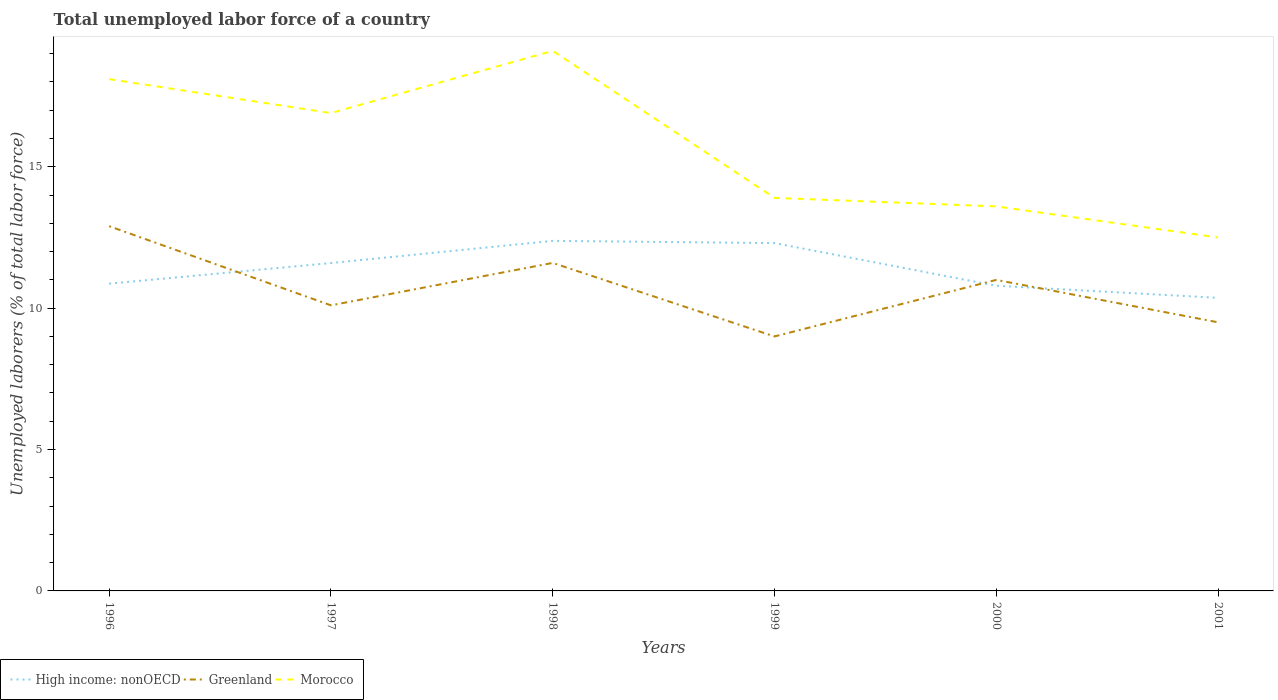Does the line corresponding to Greenland intersect with the line corresponding to High income: nonOECD?
Offer a very short reply. Yes. Across all years, what is the maximum total unemployed labor force in Morocco?
Your answer should be compact. 12.5. What is the total total unemployed labor force in Greenland in the graph?
Your answer should be compact. -0.9. What is the difference between the highest and the second highest total unemployed labor force in High income: nonOECD?
Ensure brevity in your answer.  2.01. Is the total unemployed labor force in Morocco strictly greater than the total unemployed labor force in Greenland over the years?
Ensure brevity in your answer.  No. Does the graph contain any zero values?
Ensure brevity in your answer.  No. Does the graph contain grids?
Keep it short and to the point. No. How many legend labels are there?
Provide a short and direct response. 3. How are the legend labels stacked?
Keep it short and to the point. Horizontal. What is the title of the graph?
Give a very brief answer. Total unemployed labor force of a country. What is the label or title of the Y-axis?
Provide a short and direct response. Unemployed laborers (% of total labor force). What is the Unemployed laborers (% of total labor force) in High income: nonOECD in 1996?
Keep it short and to the point. 10.87. What is the Unemployed laborers (% of total labor force) of Greenland in 1996?
Offer a very short reply. 12.9. What is the Unemployed laborers (% of total labor force) of Morocco in 1996?
Your answer should be compact. 18.1. What is the Unemployed laborers (% of total labor force) of High income: nonOECD in 1997?
Keep it short and to the point. 11.6. What is the Unemployed laborers (% of total labor force) in Greenland in 1997?
Keep it short and to the point. 10.1. What is the Unemployed laborers (% of total labor force) in Morocco in 1997?
Provide a succinct answer. 16.9. What is the Unemployed laborers (% of total labor force) of High income: nonOECD in 1998?
Ensure brevity in your answer.  12.38. What is the Unemployed laborers (% of total labor force) of Greenland in 1998?
Your answer should be very brief. 11.6. What is the Unemployed laborers (% of total labor force) in Morocco in 1998?
Your answer should be compact. 19.1. What is the Unemployed laborers (% of total labor force) of High income: nonOECD in 1999?
Keep it short and to the point. 12.3. What is the Unemployed laborers (% of total labor force) of Greenland in 1999?
Provide a short and direct response. 9. What is the Unemployed laborers (% of total labor force) of Morocco in 1999?
Provide a short and direct response. 13.9. What is the Unemployed laborers (% of total labor force) of High income: nonOECD in 2000?
Keep it short and to the point. 10.79. What is the Unemployed laborers (% of total labor force) in Greenland in 2000?
Your answer should be very brief. 11. What is the Unemployed laborers (% of total labor force) in Morocco in 2000?
Provide a succinct answer. 13.6. What is the Unemployed laborers (% of total labor force) of High income: nonOECD in 2001?
Offer a very short reply. 10.37. What is the Unemployed laborers (% of total labor force) of Greenland in 2001?
Make the answer very short. 9.5. What is the Unemployed laborers (% of total labor force) in Morocco in 2001?
Keep it short and to the point. 12.5. Across all years, what is the maximum Unemployed laborers (% of total labor force) of High income: nonOECD?
Give a very brief answer. 12.38. Across all years, what is the maximum Unemployed laborers (% of total labor force) of Greenland?
Make the answer very short. 12.9. Across all years, what is the maximum Unemployed laborers (% of total labor force) of Morocco?
Your response must be concise. 19.1. Across all years, what is the minimum Unemployed laborers (% of total labor force) of High income: nonOECD?
Provide a short and direct response. 10.37. Across all years, what is the minimum Unemployed laborers (% of total labor force) in Greenland?
Offer a terse response. 9. Across all years, what is the minimum Unemployed laborers (% of total labor force) of Morocco?
Your answer should be compact. 12.5. What is the total Unemployed laborers (% of total labor force) of High income: nonOECD in the graph?
Your response must be concise. 68.3. What is the total Unemployed laborers (% of total labor force) in Greenland in the graph?
Keep it short and to the point. 64.1. What is the total Unemployed laborers (% of total labor force) in Morocco in the graph?
Make the answer very short. 94.1. What is the difference between the Unemployed laborers (% of total labor force) in High income: nonOECD in 1996 and that in 1997?
Your response must be concise. -0.73. What is the difference between the Unemployed laborers (% of total labor force) in Greenland in 1996 and that in 1997?
Your response must be concise. 2.8. What is the difference between the Unemployed laborers (% of total labor force) in Morocco in 1996 and that in 1997?
Provide a succinct answer. 1.2. What is the difference between the Unemployed laborers (% of total labor force) of High income: nonOECD in 1996 and that in 1998?
Ensure brevity in your answer.  -1.51. What is the difference between the Unemployed laborers (% of total labor force) of Greenland in 1996 and that in 1998?
Your answer should be compact. 1.3. What is the difference between the Unemployed laborers (% of total labor force) of Morocco in 1996 and that in 1998?
Give a very brief answer. -1. What is the difference between the Unemployed laborers (% of total labor force) in High income: nonOECD in 1996 and that in 1999?
Provide a short and direct response. -1.44. What is the difference between the Unemployed laborers (% of total labor force) in Morocco in 1996 and that in 1999?
Your answer should be compact. 4.2. What is the difference between the Unemployed laborers (% of total labor force) in High income: nonOECD in 1996 and that in 2000?
Your response must be concise. 0.07. What is the difference between the Unemployed laborers (% of total labor force) of Greenland in 1996 and that in 2000?
Give a very brief answer. 1.9. What is the difference between the Unemployed laborers (% of total labor force) of Morocco in 1996 and that in 2000?
Ensure brevity in your answer.  4.5. What is the difference between the Unemployed laborers (% of total labor force) of High income: nonOECD in 1996 and that in 2001?
Your answer should be very brief. 0.5. What is the difference between the Unemployed laborers (% of total labor force) of Greenland in 1996 and that in 2001?
Make the answer very short. 3.4. What is the difference between the Unemployed laborers (% of total labor force) in High income: nonOECD in 1997 and that in 1998?
Keep it short and to the point. -0.78. What is the difference between the Unemployed laborers (% of total labor force) of Greenland in 1997 and that in 1998?
Offer a very short reply. -1.5. What is the difference between the Unemployed laborers (% of total labor force) of High income: nonOECD in 1997 and that in 1999?
Ensure brevity in your answer.  -0.71. What is the difference between the Unemployed laborers (% of total labor force) in High income: nonOECD in 1997 and that in 2000?
Your answer should be compact. 0.8. What is the difference between the Unemployed laborers (% of total labor force) of Greenland in 1997 and that in 2000?
Provide a succinct answer. -0.9. What is the difference between the Unemployed laborers (% of total labor force) in Morocco in 1997 and that in 2000?
Your answer should be compact. 3.3. What is the difference between the Unemployed laborers (% of total labor force) in High income: nonOECD in 1997 and that in 2001?
Provide a succinct answer. 1.23. What is the difference between the Unemployed laborers (% of total labor force) in Greenland in 1997 and that in 2001?
Give a very brief answer. 0.6. What is the difference between the Unemployed laborers (% of total labor force) of High income: nonOECD in 1998 and that in 1999?
Provide a succinct answer. 0.08. What is the difference between the Unemployed laborers (% of total labor force) in Greenland in 1998 and that in 1999?
Your answer should be compact. 2.6. What is the difference between the Unemployed laborers (% of total labor force) in High income: nonOECD in 1998 and that in 2000?
Your response must be concise. 1.59. What is the difference between the Unemployed laborers (% of total labor force) in Greenland in 1998 and that in 2000?
Make the answer very short. 0.6. What is the difference between the Unemployed laborers (% of total labor force) of High income: nonOECD in 1998 and that in 2001?
Ensure brevity in your answer.  2.01. What is the difference between the Unemployed laborers (% of total labor force) in High income: nonOECD in 1999 and that in 2000?
Offer a terse response. 1.51. What is the difference between the Unemployed laborers (% of total labor force) of Greenland in 1999 and that in 2000?
Your answer should be very brief. -2. What is the difference between the Unemployed laborers (% of total labor force) of Morocco in 1999 and that in 2000?
Offer a very short reply. 0.3. What is the difference between the Unemployed laborers (% of total labor force) in High income: nonOECD in 1999 and that in 2001?
Offer a terse response. 1.94. What is the difference between the Unemployed laborers (% of total labor force) of Morocco in 1999 and that in 2001?
Offer a terse response. 1.4. What is the difference between the Unemployed laborers (% of total labor force) in High income: nonOECD in 2000 and that in 2001?
Give a very brief answer. 0.43. What is the difference between the Unemployed laborers (% of total labor force) of Morocco in 2000 and that in 2001?
Your answer should be compact. 1.1. What is the difference between the Unemployed laborers (% of total labor force) in High income: nonOECD in 1996 and the Unemployed laborers (% of total labor force) in Greenland in 1997?
Provide a short and direct response. 0.77. What is the difference between the Unemployed laborers (% of total labor force) of High income: nonOECD in 1996 and the Unemployed laborers (% of total labor force) of Morocco in 1997?
Your answer should be compact. -6.03. What is the difference between the Unemployed laborers (% of total labor force) of Greenland in 1996 and the Unemployed laborers (% of total labor force) of Morocco in 1997?
Keep it short and to the point. -4. What is the difference between the Unemployed laborers (% of total labor force) of High income: nonOECD in 1996 and the Unemployed laborers (% of total labor force) of Greenland in 1998?
Give a very brief answer. -0.73. What is the difference between the Unemployed laborers (% of total labor force) of High income: nonOECD in 1996 and the Unemployed laborers (% of total labor force) of Morocco in 1998?
Offer a very short reply. -8.23. What is the difference between the Unemployed laborers (% of total labor force) in High income: nonOECD in 1996 and the Unemployed laborers (% of total labor force) in Greenland in 1999?
Give a very brief answer. 1.87. What is the difference between the Unemployed laborers (% of total labor force) of High income: nonOECD in 1996 and the Unemployed laborers (% of total labor force) of Morocco in 1999?
Ensure brevity in your answer.  -3.03. What is the difference between the Unemployed laborers (% of total labor force) in Greenland in 1996 and the Unemployed laborers (% of total labor force) in Morocco in 1999?
Ensure brevity in your answer.  -1. What is the difference between the Unemployed laborers (% of total labor force) in High income: nonOECD in 1996 and the Unemployed laborers (% of total labor force) in Greenland in 2000?
Provide a short and direct response. -0.13. What is the difference between the Unemployed laborers (% of total labor force) of High income: nonOECD in 1996 and the Unemployed laborers (% of total labor force) of Morocco in 2000?
Your response must be concise. -2.73. What is the difference between the Unemployed laborers (% of total labor force) in Greenland in 1996 and the Unemployed laborers (% of total labor force) in Morocco in 2000?
Offer a very short reply. -0.7. What is the difference between the Unemployed laborers (% of total labor force) of High income: nonOECD in 1996 and the Unemployed laborers (% of total labor force) of Greenland in 2001?
Your answer should be compact. 1.37. What is the difference between the Unemployed laborers (% of total labor force) of High income: nonOECD in 1996 and the Unemployed laborers (% of total labor force) of Morocco in 2001?
Make the answer very short. -1.63. What is the difference between the Unemployed laborers (% of total labor force) in High income: nonOECD in 1997 and the Unemployed laborers (% of total labor force) in Greenland in 1998?
Offer a very short reply. -0. What is the difference between the Unemployed laborers (% of total labor force) of High income: nonOECD in 1997 and the Unemployed laborers (% of total labor force) of Morocco in 1998?
Provide a short and direct response. -7.5. What is the difference between the Unemployed laborers (% of total labor force) in Greenland in 1997 and the Unemployed laborers (% of total labor force) in Morocco in 1998?
Offer a terse response. -9. What is the difference between the Unemployed laborers (% of total labor force) in High income: nonOECD in 1997 and the Unemployed laborers (% of total labor force) in Greenland in 1999?
Provide a short and direct response. 2.6. What is the difference between the Unemployed laborers (% of total labor force) of High income: nonOECD in 1997 and the Unemployed laborers (% of total labor force) of Morocco in 1999?
Make the answer very short. -2.3. What is the difference between the Unemployed laborers (% of total labor force) of High income: nonOECD in 1997 and the Unemployed laborers (% of total labor force) of Greenland in 2000?
Offer a terse response. 0.6. What is the difference between the Unemployed laborers (% of total labor force) in High income: nonOECD in 1997 and the Unemployed laborers (% of total labor force) in Morocco in 2000?
Provide a succinct answer. -2. What is the difference between the Unemployed laborers (% of total labor force) in Greenland in 1997 and the Unemployed laborers (% of total labor force) in Morocco in 2000?
Provide a short and direct response. -3.5. What is the difference between the Unemployed laborers (% of total labor force) in High income: nonOECD in 1997 and the Unemployed laborers (% of total labor force) in Greenland in 2001?
Keep it short and to the point. 2.1. What is the difference between the Unemployed laborers (% of total labor force) of High income: nonOECD in 1997 and the Unemployed laborers (% of total labor force) of Morocco in 2001?
Offer a very short reply. -0.9. What is the difference between the Unemployed laborers (% of total labor force) in High income: nonOECD in 1998 and the Unemployed laborers (% of total labor force) in Greenland in 1999?
Offer a very short reply. 3.38. What is the difference between the Unemployed laborers (% of total labor force) in High income: nonOECD in 1998 and the Unemployed laborers (% of total labor force) in Morocco in 1999?
Offer a terse response. -1.52. What is the difference between the Unemployed laborers (% of total labor force) in High income: nonOECD in 1998 and the Unemployed laborers (% of total labor force) in Greenland in 2000?
Offer a very short reply. 1.38. What is the difference between the Unemployed laborers (% of total labor force) in High income: nonOECD in 1998 and the Unemployed laborers (% of total labor force) in Morocco in 2000?
Provide a short and direct response. -1.22. What is the difference between the Unemployed laborers (% of total labor force) of High income: nonOECD in 1998 and the Unemployed laborers (% of total labor force) of Greenland in 2001?
Ensure brevity in your answer.  2.88. What is the difference between the Unemployed laborers (% of total labor force) of High income: nonOECD in 1998 and the Unemployed laborers (% of total labor force) of Morocco in 2001?
Keep it short and to the point. -0.12. What is the difference between the Unemployed laborers (% of total labor force) in High income: nonOECD in 1999 and the Unemployed laborers (% of total labor force) in Greenland in 2000?
Your answer should be very brief. 1.3. What is the difference between the Unemployed laborers (% of total labor force) of High income: nonOECD in 1999 and the Unemployed laborers (% of total labor force) of Morocco in 2000?
Give a very brief answer. -1.3. What is the difference between the Unemployed laborers (% of total labor force) in Greenland in 1999 and the Unemployed laborers (% of total labor force) in Morocco in 2000?
Make the answer very short. -4.6. What is the difference between the Unemployed laborers (% of total labor force) of High income: nonOECD in 1999 and the Unemployed laborers (% of total labor force) of Greenland in 2001?
Your response must be concise. 2.8. What is the difference between the Unemployed laborers (% of total labor force) in High income: nonOECD in 1999 and the Unemployed laborers (% of total labor force) in Morocco in 2001?
Offer a terse response. -0.2. What is the difference between the Unemployed laborers (% of total labor force) of High income: nonOECD in 2000 and the Unemployed laborers (% of total labor force) of Greenland in 2001?
Offer a terse response. 1.29. What is the difference between the Unemployed laborers (% of total labor force) in High income: nonOECD in 2000 and the Unemployed laborers (% of total labor force) in Morocco in 2001?
Ensure brevity in your answer.  -1.71. What is the difference between the Unemployed laborers (% of total labor force) in Greenland in 2000 and the Unemployed laborers (% of total labor force) in Morocco in 2001?
Provide a succinct answer. -1.5. What is the average Unemployed laborers (% of total labor force) in High income: nonOECD per year?
Provide a succinct answer. 11.38. What is the average Unemployed laborers (% of total labor force) in Greenland per year?
Your answer should be very brief. 10.68. What is the average Unemployed laborers (% of total labor force) in Morocco per year?
Your response must be concise. 15.68. In the year 1996, what is the difference between the Unemployed laborers (% of total labor force) of High income: nonOECD and Unemployed laborers (% of total labor force) of Greenland?
Provide a succinct answer. -2.03. In the year 1996, what is the difference between the Unemployed laborers (% of total labor force) of High income: nonOECD and Unemployed laborers (% of total labor force) of Morocco?
Your response must be concise. -7.23. In the year 1996, what is the difference between the Unemployed laborers (% of total labor force) of Greenland and Unemployed laborers (% of total labor force) of Morocco?
Offer a terse response. -5.2. In the year 1997, what is the difference between the Unemployed laborers (% of total labor force) in High income: nonOECD and Unemployed laborers (% of total labor force) in Greenland?
Your answer should be very brief. 1.5. In the year 1997, what is the difference between the Unemployed laborers (% of total labor force) of High income: nonOECD and Unemployed laborers (% of total labor force) of Morocco?
Offer a terse response. -5.3. In the year 1998, what is the difference between the Unemployed laborers (% of total labor force) of High income: nonOECD and Unemployed laborers (% of total labor force) of Greenland?
Provide a succinct answer. 0.78. In the year 1998, what is the difference between the Unemployed laborers (% of total labor force) of High income: nonOECD and Unemployed laborers (% of total labor force) of Morocco?
Your answer should be very brief. -6.72. In the year 1998, what is the difference between the Unemployed laborers (% of total labor force) in Greenland and Unemployed laborers (% of total labor force) in Morocco?
Make the answer very short. -7.5. In the year 1999, what is the difference between the Unemployed laborers (% of total labor force) in High income: nonOECD and Unemployed laborers (% of total labor force) in Greenland?
Provide a short and direct response. 3.3. In the year 1999, what is the difference between the Unemployed laborers (% of total labor force) in High income: nonOECD and Unemployed laborers (% of total labor force) in Morocco?
Offer a very short reply. -1.6. In the year 1999, what is the difference between the Unemployed laborers (% of total labor force) in Greenland and Unemployed laborers (% of total labor force) in Morocco?
Ensure brevity in your answer.  -4.9. In the year 2000, what is the difference between the Unemployed laborers (% of total labor force) of High income: nonOECD and Unemployed laborers (% of total labor force) of Greenland?
Your answer should be very brief. -0.21. In the year 2000, what is the difference between the Unemployed laborers (% of total labor force) in High income: nonOECD and Unemployed laborers (% of total labor force) in Morocco?
Provide a succinct answer. -2.81. In the year 2001, what is the difference between the Unemployed laborers (% of total labor force) in High income: nonOECD and Unemployed laborers (% of total labor force) in Greenland?
Provide a short and direct response. 0.87. In the year 2001, what is the difference between the Unemployed laborers (% of total labor force) of High income: nonOECD and Unemployed laborers (% of total labor force) of Morocco?
Provide a succinct answer. -2.13. What is the ratio of the Unemployed laborers (% of total labor force) of High income: nonOECD in 1996 to that in 1997?
Offer a terse response. 0.94. What is the ratio of the Unemployed laborers (% of total labor force) of Greenland in 1996 to that in 1997?
Give a very brief answer. 1.28. What is the ratio of the Unemployed laborers (% of total labor force) in Morocco in 1996 to that in 1997?
Provide a succinct answer. 1.07. What is the ratio of the Unemployed laborers (% of total labor force) in High income: nonOECD in 1996 to that in 1998?
Your answer should be very brief. 0.88. What is the ratio of the Unemployed laborers (% of total labor force) of Greenland in 1996 to that in 1998?
Your answer should be compact. 1.11. What is the ratio of the Unemployed laborers (% of total labor force) of Morocco in 1996 to that in 1998?
Your answer should be very brief. 0.95. What is the ratio of the Unemployed laborers (% of total labor force) of High income: nonOECD in 1996 to that in 1999?
Provide a succinct answer. 0.88. What is the ratio of the Unemployed laborers (% of total labor force) in Greenland in 1996 to that in 1999?
Give a very brief answer. 1.43. What is the ratio of the Unemployed laborers (% of total labor force) of Morocco in 1996 to that in 1999?
Ensure brevity in your answer.  1.3. What is the ratio of the Unemployed laborers (% of total labor force) in High income: nonOECD in 1996 to that in 2000?
Keep it short and to the point. 1.01. What is the ratio of the Unemployed laborers (% of total labor force) in Greenland in 1996 to that in 2000?
Offer a terse response. 1.17. What is the ratio of the Unemployed laborers (% of total labor force) of Morocco in 1996 to that in 2000?
Offer a terse response. 1.33. What is the ratio of the Unemployed laborers (% of total labor force) of High income: nonOECD in 1996 to that in 2001?
Keep it short and to the point. 1.05. What is the ratio of the Unemployed laborers (% of total labor force) of Greenland in 1996 to that in 2001?
Your answer should be very brief. 1.36. What is the ratio of the Unemployed laborers (% of total labor force) in Morocco in 1996 to that in 2001?
Make the answer very short. 1.45. What is the ratio of the Unemployed laborers (% of total labor force) in High income: nonOECD in 1997 to that in 1998?
Provide a short and direct response. 0.94. What is the ratio of the Unemployed laborers (% of total labor force) of Greenland in 1997 to that in 1998?
Provide a succinct answer. 0.87. What is the ratio of the Unemployed laborers (% of total labor force) of Morocco in 1997 to that in 1998?
Ensure brevity in your answer.  0.88. What is the ratio of the Unemployed laborers (% of total labor force) in High income: nonOECD in 1997 to that in 1999?
Your answer should be compact. 0.94. What is the ratio of the Unemployed laborers (% of total labor force) of Greenland in 1997 to that in 1999?
Provide a short and direct response. 1.12. What is the ratio of the Unemployed laborers (% of total labor force) in Morocco in 1997 to that in 1999?
Your answer should be very brief. 1.22. What is the ratio of the Unemployed laborers (% of total labor force) in High income: nonOECD in 1997 to that in 2000?
Offer a very short reply. 1.07. What is the ratio of the Unemployed laborers (% of total labor force) in Greenland in 1997 to that in 2000?
Provide a short and direct response. 0.92. What is the ratio of the Unemployed laborers (% of total labor force) in Morocco in 1997 to that in 2000?
Provide a short and direct response. 1.24. What is the ratio of the Unemployed laborers (% of total labor force) of High income: nonOECD in 1997 to that in 2001?
Provide a succinct answer. 1.12. What is the ratio of the Unemployed laborers (% of total labor force) in Greenland in 1997 to that in 2001?
Ensure brevity in your answer.  1.06. What is the ratio of the Unemployed laborers (% of total labor force) in Morocco in 1997 to that in 2001?
Keep it short and to the point. 1.35. What is the ratio of the Unemployed laborers (% of total labor force) of High income: nonOECD in 1998 to that in 1999?
Offer a very short reply. 1.01. What is the ratio of the Unemployed laborers (% of total labor force) of Greenland in 1998 to that in 1999?
Your response must be concise. 1.29. What is the ratio of the Unemployed laborers (% of total labor force) in Morocco in 1998 to that in 1999?
Offer a very short reply. 1.37. What is the ratio of the Unemployed laborers (% of total labor force) in High income: nonOECD in 1998 to that in 2000?
Keep it short and to the point. 1.15. What is the ratio of the Unemployed laborers (% of total labor force) of Greenland in 1998 to that in 2000?
Your response must be concise. 1.05. What is the ratio of the Unemployed laborers (% of total labor force) of Morocco in 1998 to that in 2000?
Your answer should be very brief. 1.4. What is the ratio of the Unemployed laborers (% of total labor force) of High income: nonOECD in 1998 to that in 2001?
Your answer should be compact. 1.19. What is the ratio of the Unemployed laborers (% of total labor force) of Greenland in 1998 to that in 2001?
Keep it short and to the point. 1.22. What is the ratio of the Unemployed laborers (% of total labor force) in Morocco in 1998 to that in 2001?
Give a very brief answer. 1.53. What is the ratio of the Unemployed laborers (% of total labor force) in High income: nonOECD in 1999 to that in 2000?
Provide a short and direct response. 1.14. What is the ratio of the Unemployed laborers (% of total labor force) of Greenland in 1999 to that in 2000?
Your answer should be very brief. 0.82. What is the ratio of the Unemployed laborers (% of total labor force) of Morocco in 1999 to that in 2000?
Offer a terse response. 1.02. What is the ratio of the Unemployed laborers (% of total labor force) of High income: nonOECD in 1999 to that in 2001?
Ensure brevity in your answer.  1.19. What is the ratio of the Unemployed laborers (% of total labor force) in Morocco in 1999 to that in 2001?
Provide a short and direct response. 1.11. What is the ratio of the Unemployed laborers (% of total labor force) of High income: nonOECD in 2000 to that in 2001?
Provide a short and direct response. 1.04. What is the ratio of the Unemployed laborers (% of total labor force) in Greenland in 2000 to that in 2001?
Give a very brief answer. 1.16. What is the ratio of the Unemployed laborers (% of total labor force) of Morocco in 2000 to that in 2001?
Make the answer very short. 1.09. What is the difference between the highest and the second highest Unemployed laborers (% of total labor force) of High income: nonOECD?
Your response must be concise. 0.08. What is the difference between the highest and the second highest Unemployed laborers (% of total labor force) in Greenland?
Your response must be concise. 1.3. What is the difference between the highest and the second highest Unemployed laborers (% of total labor force) in Morocco?
Provide a succinct answer. 1. What is the difference between the highest and the lowest Unemployed laborers (% of total labor force) of High income: nonOECD?
Make the answer very short. 2.01. 